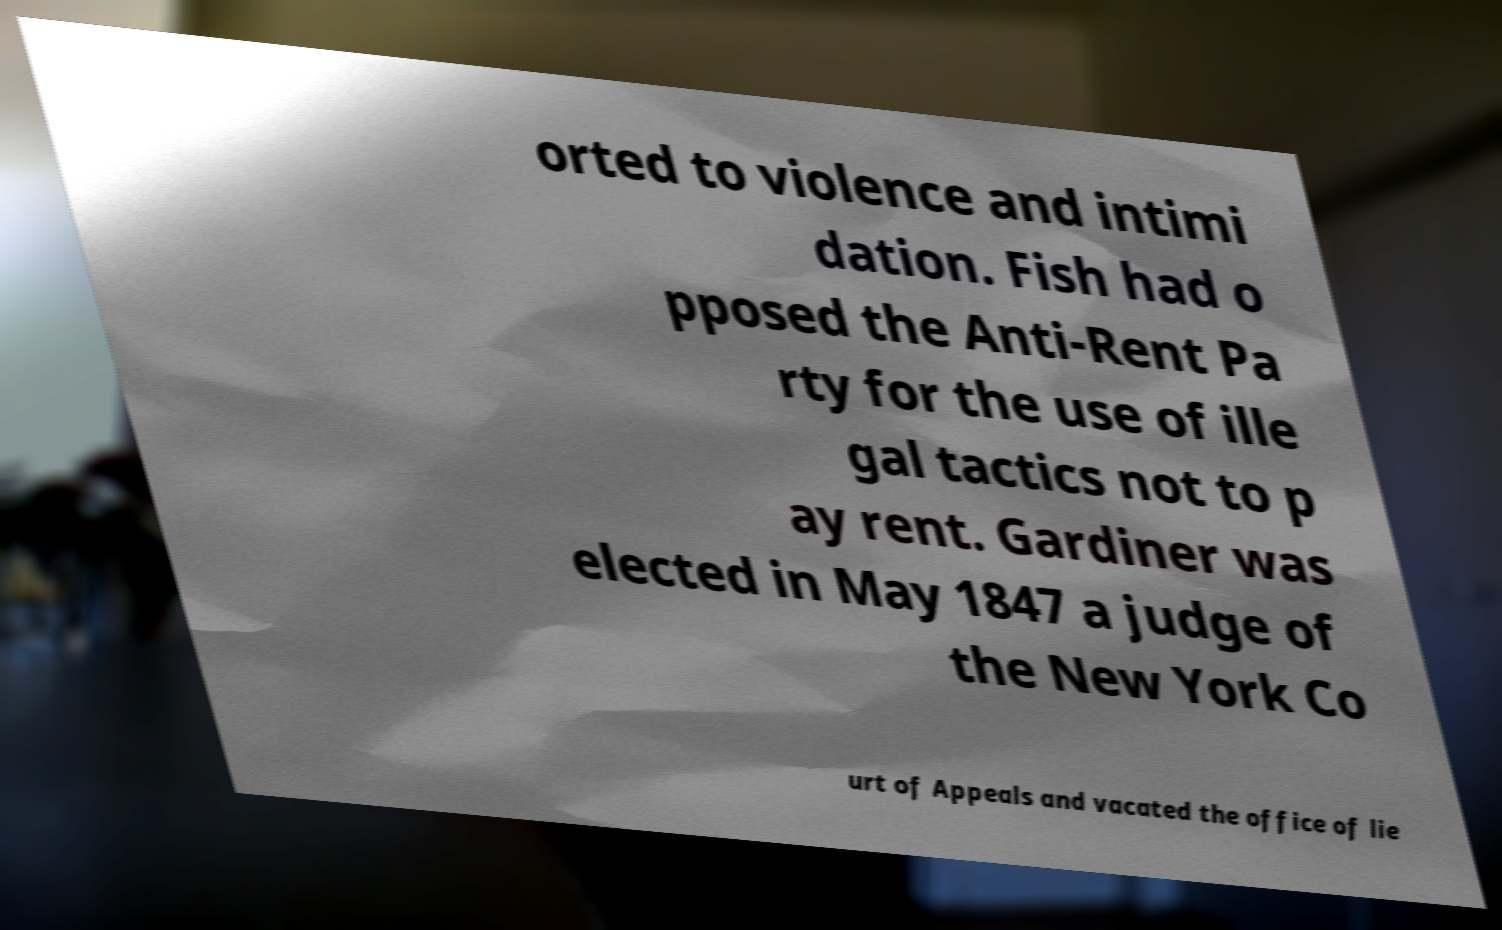Can you read and provide the text displayed in the image?This photo seems to have some interesting text. Can you extract and type it out for me? orted to violence and intimi dation. Fish had o pposed the Anti-Rent Pa rty for the use of ille gal tactics not to p ay rent. Gardiner was elected in May 1847 a judge of the New York Co urt of Appeals and vacated the office of lie 